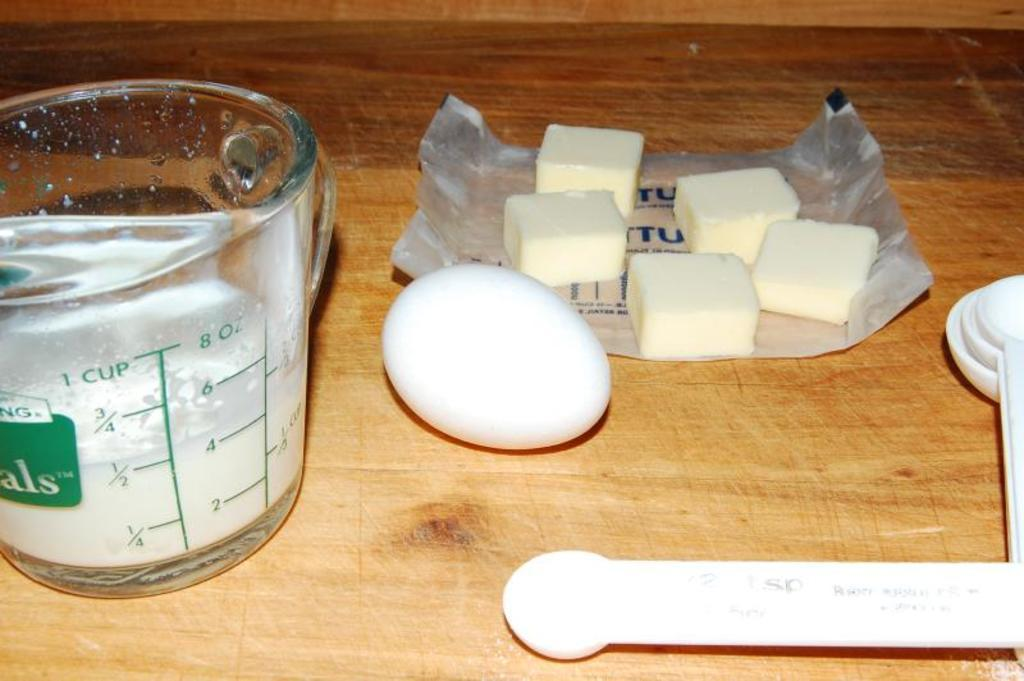Provide a one-sentence caption for the provided image. Half of a cup of flour sits in a measuring cup on a countertop. 